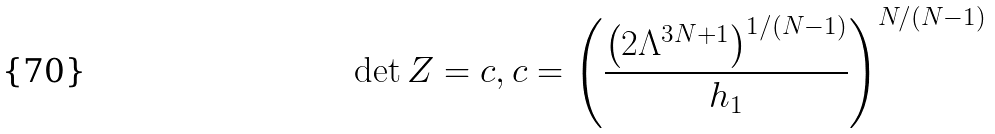<formula> <loc_0><loc_0><loc_500><loc_500>\det Z = c , c = \left ( \frac { \left ( 2 \Lambda ^ { 3 N + 1 } \right ) ^ { 1 / ( N - 1 ) } } { h _ { 1 } } \right ) ^ { N / ( N - 1 ) }</formula> 